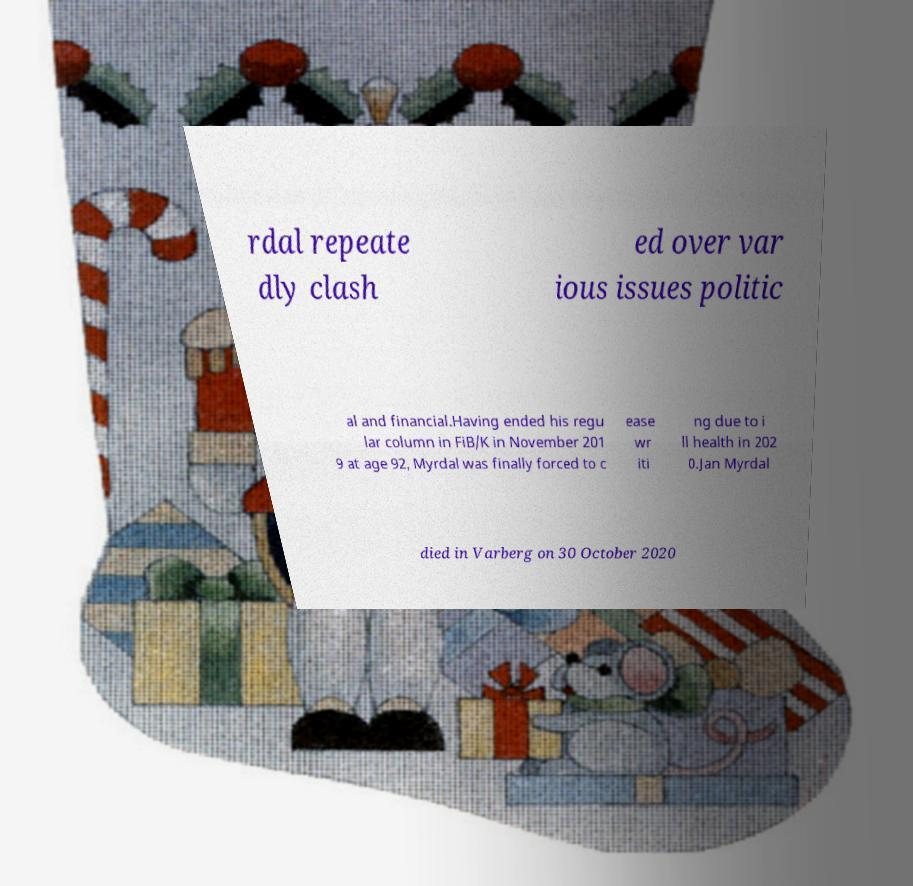Can you accurately transcribe the text from the provided image for me? rdal repeate dly clash ed over var ious issues politic al and financial.Having ended his regu lar column in FiB/K in November 201 9 at age 92, Myrdal was finally forced to c ease wr iti ng due to i ll health in 202 0.Jan Myrdal died in Varberg on 30 October 2020 